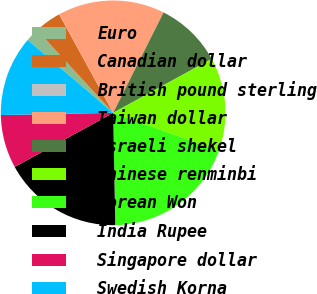Convert chart to OTSL. <chart><loc_0><loc_0><loc_500><loc_500><pie_chart><fcel>Euro<fcel>Canadian dollar<fcel>British pound sterling<fcel>Taiwan dollar<fcel>Israeli shekel<fcel>Chinese renminbi<fcel>Korean Won<fcel>India Rupee<fcel>Singapore dollar<fcel>Swedish Korna<nl><fcel>1.93%<fcel>3.85%<fcel>0.01%<fcel>15.38%<fcel>9.62%<fcel>13.46%<fcel>19.22%<fcel>17.3%<fcel>7.69%<fcel>11.54%<nl></chart> 